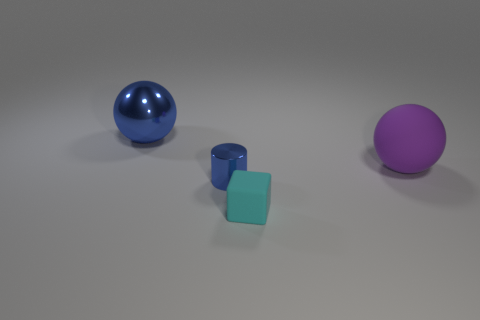Is there anything else that is the same shape as the tiny matte thing?
Give a very brief answer. No. What size is the thing behind the big object that is to the right of the blue shiny cylinder?
Provide a succinct answer. Large. Does the large object that is on the left side of the cyan matte cube have the same shape as the tiny cyan matte thing?
Provide a succinct answer. No. What is the material of the other large purple thing that is the same shape as the big shiny thing?
Provide a succinct answer. Rubber. What number of objects are blue objects that are in front of the large blue object or matte things to the right of the small cyan object?
Offer a terse response. 2. Does the large metal ball have the same color as the metallic thing in front of the purple rubber ball?
Make the answer very short. Yes. There is a blue object that is made of the same material as the tiny blue cylinder; what shape is it?
Give a very brief answer. Sphere. How many tiny purple cylinders are there?
Make the answer very short. 0. How many things are either large spheres that are left of the small cube or cyan objects?
Make the answer very short. 2. Is the color of the ball behind the matte ball the same as the shiny cylinder?
Give a very brief answer. Yes. 